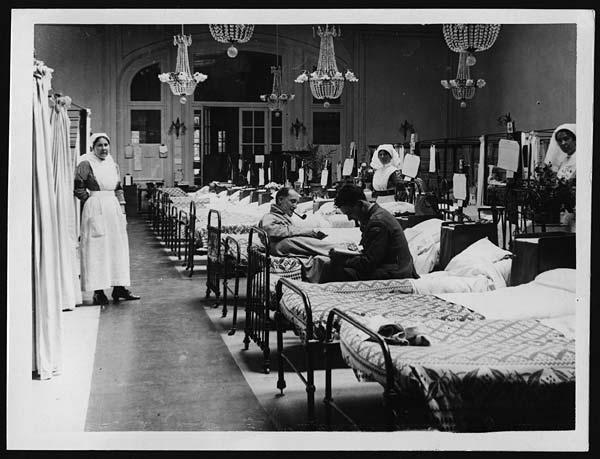Is someone smoking in the picture?
Concise answer only. Yes. Was this photo taken in a hospital?
Quick response, please. Yes. How do you know this photo was taken long ago?
Concise answer only. Black and white. 